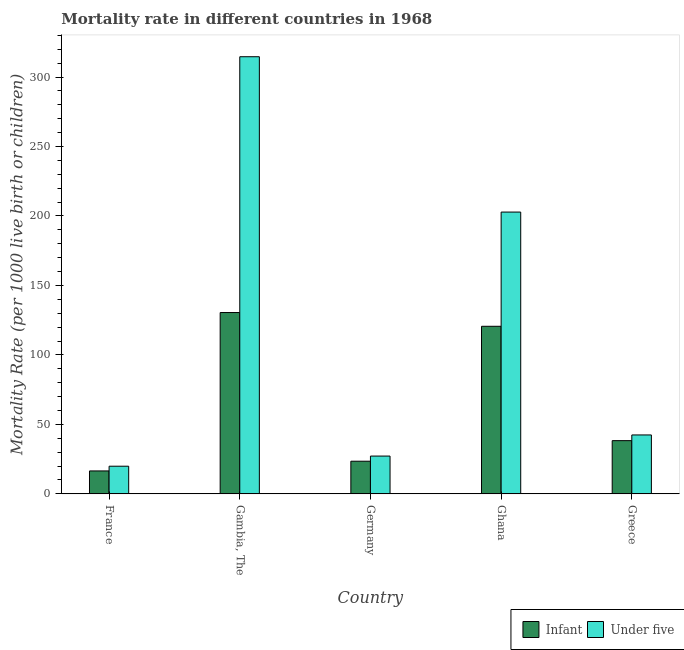How many different coloured bars are there?
Offer a terse response. 2. How many bars are there on the 1st tick from the left?
Provide a short and direct response. 2. How many bars are there on the 5th tick from the right?
Your response must be concise. 2. What is the label of the 4th group of bars from the left?
Your answer should be very brief. Ghana. In how many cases, is the number of bars for a given country not equal to the number of legend labels?
Provide a short and direct response. 0. Across all countries, what is the maximum under-5 mortality rate?
Keep it short and to the point. 314.6. Across all countries, what is the minimum infant mortality rate?
Offer a very short reply. 16.5. In which country was the under-5 mortality rate maximum?
Offer a terse response. Gambia, The. In which country was the under-5 mortality rate minimum?
Keep it short and to the point. France. What is the total under-5 mortality rate in the graph?
Your response must be concise. 606.9. What is the difference between the under-5 mortality rate in France and that in Gambia, The?
Your answer should be very brief. -294.7. What is the difference between the under-5 mortality rate in Ghana and the infant mortality rate in Gambia, The?
Your answer should be very brief. 72.3. What is the average under-5 mortality rate per country?
Provide a short and direct response. 121.38. What is the difference between the infant mortality rate and under-5 mortality rate in Gambia, The?
Ensure brevity in your answer.  -184.1. What is the ratio of the infant mortality rate in Germany to that in Greece?
Make the answer very short. 0.61. Is the difference between the under-5 mortality rate in France and Gambia, The greater than the difference between the infant mortality rate in France and Gambia, The?
Offer a very short reply. No. What is the difference between the highest and the second highest under-5 mortality rate?
Keep it short and to the point. 111.8. What is the difference between the highest and the lowest infant mortality rate?
Keep it short and to the point. 114. In how many countries, is the infant mortality rate greater than the average infant mortality rate taken over all countries?
Keep it short and to the point. 2. What does the 2nd bar from the left in Germany represents?
Offer a very short reply. Under five. What does the 1st bar from the right in France represents?
Make the answer very short. Under five. How many countries are there in the graph?
Your answer should be very brief. 5. What is the difference between two consecutive major ticks on the Y-axis?
Your answer should be compact. 50. Are the values on the major ticks of Y-axis written in scientific E-notation?
Your response must be concise. No. Does the graph contain any zero values?
Ensure brevity in your answer.  No. How are the legend labels stacked?
Provide a short and direct response. Horizontal. What is the title of the graph?
Your response must be concise. Mortality rate in different countries in 1968. What is the label or title of the Y-axis?
Provide a succinct answer. Mortality Rate (per 1000 live birth or children). What is the Mortality Rate (per 1000 live birth or children) in Infant in Gambia, The?
Provide a short and direct response. 130.5. What is the Mortality Rate (per 1000 live birth or children) in Under five in Gambia, The?
Your response must be concise. 314.6. What is the Mortality Rate (per 1000 live birth or children) of Infant in Germany?
Ensure brevity in your answer.  23.5. What is the Mortality Rate (per 1000 live birth or children) in Under five in Germany?
Offer a terse response. 27.2. What is the Mortality Rate (per 1000 live birth or children) in Infant in Ghana?
Provide a short and direct response. 120.6. What is the Mortality Rate (per 1000 live birth or children) of Under five in Ghana?
Ensure brevity in your answer.  202.8. What is the Mortality Rate (per 1000 live birth or children) of Infant in Greece?
Your answer should be very brief. 38.3. What is the Mortality Rate (per 1000 live birth or children) of Under five in Greece?
Give a very brief answer. 42.4. Across all countries, what is the maximum Mortality Rate (per 1000 live birth or children) of Infant?
Offer a very short reply. 130.5. Across all countries, what is the maximum Mortality Rate (per 1000 live birth or children) of Under five?
Provide a short and direct response. 314.6. What is the total Mortality Rate (per 1000 live birth or children) in Infant in the graph?
Offer a very short reply. 329.4. What is the total Mortality Rate (per 1000 live birth or children) of Under five in the graph?
Your answer should be very brief. 606.9. What is the difference between the Mortality Rate (per 1000 live birth or children) in Infant in France and that in Gambia, The?
Keep it short and to the point. -114. What is the difference between the Mortality Rate (per 1000 live birth or children) of Under five in France and that in Gambia, The?
Give a very brief answer. -294.7. What is the difference between the Mortality Rate (per 1000 live birth or children) in Under five in France and that in Germany?
Your answer should be very brief. -7.3. What is the difference between the Mortality Rate (per 1000 live birth or children) of Infant in France and that in Ghana?
Your answer should be very brief. -104.1. What is the difference between the Mortality Rate (per 1000 live birth or children) in Under five in France and that in Ghana?
Make the answer very short. -182.9. What is the difference between the Mortality Rate (per 1000 live birth or children) of Infant in France and that in Greece?
Offer a very short reply. -21.8. What is the difference between the Mortality Rate (per 1000 live birth or children) in Under five in France and that in Greece?
Your answer should be compact. -22.5. What is the difference between the Mortality Rate (per 1000 live birth or children) in Infant in Gambia, The and that in Germany?
Provide a short and direct response. 107. What is the difference between the Mortality Rate (per 1000 live birth or children) of Under five in Gambia, The and that in Germany?
Offer a terse response. 287.4. What is the difference between the Mortality Rate (per 1000 live birth or children) of Infant in Gambia, The and that in Ghana?
Your answer should be compact. 9.9. What is the difference between the Mortality Rate (per 1000 live birth or children) of Under five in Gambia, The and that in Ghana?
Make the answer very short. 111.8. What is the difference between the Mortality Rate (per 1000 live birth or children) in Infant in Gambia, The and that in Greece?
Your answer should be compact. 92.2. What is the difference between the Mortality Rate (per 1000 live birth or children) in Under five in Gambia, The and that in Greece?
Your response must be concise. 272.2. What is the difference between the Mortality Rate (per 1000 live birth or children) of Infant in Germany and that in Ghana?
Offer a terse response. -97.1. What is the difference between the Mortality Rate (per 1000 live birth or children) of Under five in Germany and that in Ghana?
Give a very brief answer. -175.6. What is the difference between the Mortality Rate (per 1000 live birth or children) in Infant in Germany and that in Greece?
Provide a succinct answer. -14.8. What is the difference between the Mortality Rate (per 1000 live birth or children) in Under five in Germany and that in Greece?
Give a very brief answer. -15.2. What is the difference between the Mortality Rate (per 1000 live birth or children) in Infant in Ghana and that in Greece?
Make the answer very short. 82.3. What is the difference between the Mortality Rate (per 1000 live birth or children) of Under five in Ghana and that in Greece?
Offer a very short reply. 160.4. What is the difference between the Mortality Rate (per 1000 live birth or children) in Infant in France and the Mortality Rate (per 1000 live birth or children) in Under five in Gambia, The?
Offer a terse response. -298.1. What is the difference between the Mortality Rate (per 1000 live birth or children) in Infant in France and the Mortality Rate (per 1000 live birth or children) in Under five in Ghana?
Offer a terse response. -186.3. What is the difference between the Mortality Rate (per 1000 live birth or children) of Infant in France and the Mortality Rate (per 1000 live birth or children) of Under five in Greece?
Provide a succinct answer. -25.9. What is the difference between the Mortality Rate (per 1000 live birth or children) of Infant in Gambia, The and the Mortality Rate (per 1000 live birth or children) of Under five in Germany?
Your answer should be compact. 103.3. What is the difference between the Mortality Rate (per 1000 live birth or children) of Infant in Gambia, The and the Mortality Rate (per 1000 live birth or children) of Under five in Ghana?
Give a very brief answer. -72.3. What is the difference between the Mortality Rate (per 1000 live birth or children) of Infant in Gambia, The and the Mortality Rate (per 1000 live birth or children) of Under five in Greece?
Your answer should be very brief. 88.1. What is the difference between the Mortality Rate (per 1000 live birth or children) of Infant in Germany and the Mortality Rate (per 1000 live birth or children) of Under five in Ghana?
Ensure brevity in your answer.  -179.3. What is the difference between the Mortality Rate (per 1000 live birth or children) of Infant in Germany and the Mortality Rate (per 1000 live birth or children) of Under five in Greece?
Keep it short and to the point. -18.9. What is the difference between the Mortality Rate (per 1000 live birth or children) of Infant in Ghana and the Mortality Rate (per 1000 live birth or children) of Under five in Greece?
Keep it short and to the point. 78.2. What is the average Mortality Rate (per 1000 live birth or children) in Infant per country?
Give a very brief answer. 65.88. What is the average Mortality Rate (per 1000 live birth or children) in Under five per country?
Ensure brevity in your answer.  121.38. What is the difference between the Mortality Rate (per 1000 live birth or children) in Infant and Mortality Rate (per 1000 live birth or children) in Under five in Gambia, The?
Provide a short and direct response. -184.1. What is the difference between the Mortality Rate (per 1000 live birth or children) in Infant and Mortality Rate (per 1000 live birth or children) in Under five in Germany?
Keep it short and to the point. -3.7. What is the difference between the Mortality Rate (per 1000 live birth or children) in Infant and Mortality Rate (per 1000 live birth or children) in Under five in Ghana?
Make the answer very short. -82.2. What is the difference between the Mortality Rate (per 1000 live birth or children) of Infant and Mortality Rate (per 1000 live birth or children) of Under five in Greece?
Give a very brief answer. -4.1. What is the ratio of the Mortality Rate (per 1000 live birth or children) of Infant in France to that in Gambia, The?
Your response must be concise. 0.13. What is the ratio of the Mortality Rate (per 1000 live birth or children) of Under five in France to that in Gambia, The?
Provide a short and direct response. 0.06. What is the ratio of the Mortality Rate (per 1000 live birth or children) in Infant in France to that in Germany?
Your response must be concise. 0.7. What is the ratio of the Mortality Rate (per 1000 live birth or children) in Under five in France to that in Germany?
Provide a short and direct response. 0.73. What is the ratio of the Mortality Rate (per 1000 live birth or children) of Infant in France to that in Ghana?
Provide a short and direct response. 0.14. What is the ratio of the Mortality Rate (per 1000 live birth or children) of Under five in France to that in Ghana?
Your answer should be compact. 0.1. What is the ratio of the Mortality Rate (per 1000 live birth or children) of Infant in France to that in Greece?
Offer a terse response. 0.43. What is the ratio of the Mortality Rate (per 1000 live birth or children) in Under five in France to that in Greece?
Your answer should be very brief. 0.47. What is the ratio of the Mortality Rate (per 1000 live birth or children) in Infant in Gambia, The to that in Germany?
Ensure brevity in your answer.  5.55. What is the ratio of the Mortality Rate (per 1000 live birth or children) of Under five in Gambia, The to that in Germany?
Keep it short and to the point. 11.57. What is the ratio of the Mortality Rate (per 1000 live birth or children) of Infant in Gambia, The to that in Ghana?
Provide a succinct answer. 1.08. What is the ratio of the Mortality Rate (per 1000 live birth or children) of Under five in Gambia, The to that in Ghana?
Ensure brevity in your answer.  1.55. What is the ratio of the Mortality Rate (per 1000 live birth or children) of Infant in Gambia, The to that in Greece?
Offer a terse response. 3.41. What is the ratio of the Mortality Rate (per 1000 live birth or children) of Under five in Gambia, The to that in Greece?
Your answer should be compact. 7.42. What is the ratio of the Mortality Rate (per 1000 live birth or children) of Infant in Germany to that in Ghana?
Offer a terse response. 0.19. What is the ratio of the Mortality Rate (per 1000 live birth or children) in Under five in Germany to that in Ghana?
Give a very brief answer. 0.13. What is the ratio of the Mortality Rate (per 1000 live birth or children) of Infant in Germany to that in Greece?
Your response must be concise. 0.61. What is the ratio of the Mortality Rate (per 1000 live birth or children) of Under five in Germany to that in Greece?
Make the answer very short. 0.64. What is the ratio of the Mortality Rate (per 1000 live birth or children) in Infant in Ghana to that in Greece?
Your response must be concise. 3.15. What is the ratio of the Mortality Rate (per 1000 live birth or children) in Under five in Ghana to that in Greece?
Offer a terse response. 4.78. What is the difference between the highest and the second highest Mortality Rate (per 1000 live birth or children) of Under five?
Offer a very short reply. 111.8. What is the difference between the highest and the lowest Mortality Rate (per 1000 live birth or children) of Infant?
Offer a very short reply. 114. What is the difference between the highest and the lowest Mortality Rate (per 1000 live birth or children) of Under five?
Your answer should be very brief. 294.7. 